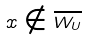<formula> <loc_0><loc_0><loc_500><loc_500>x \notin \overline { W _ { U } }</formula> 